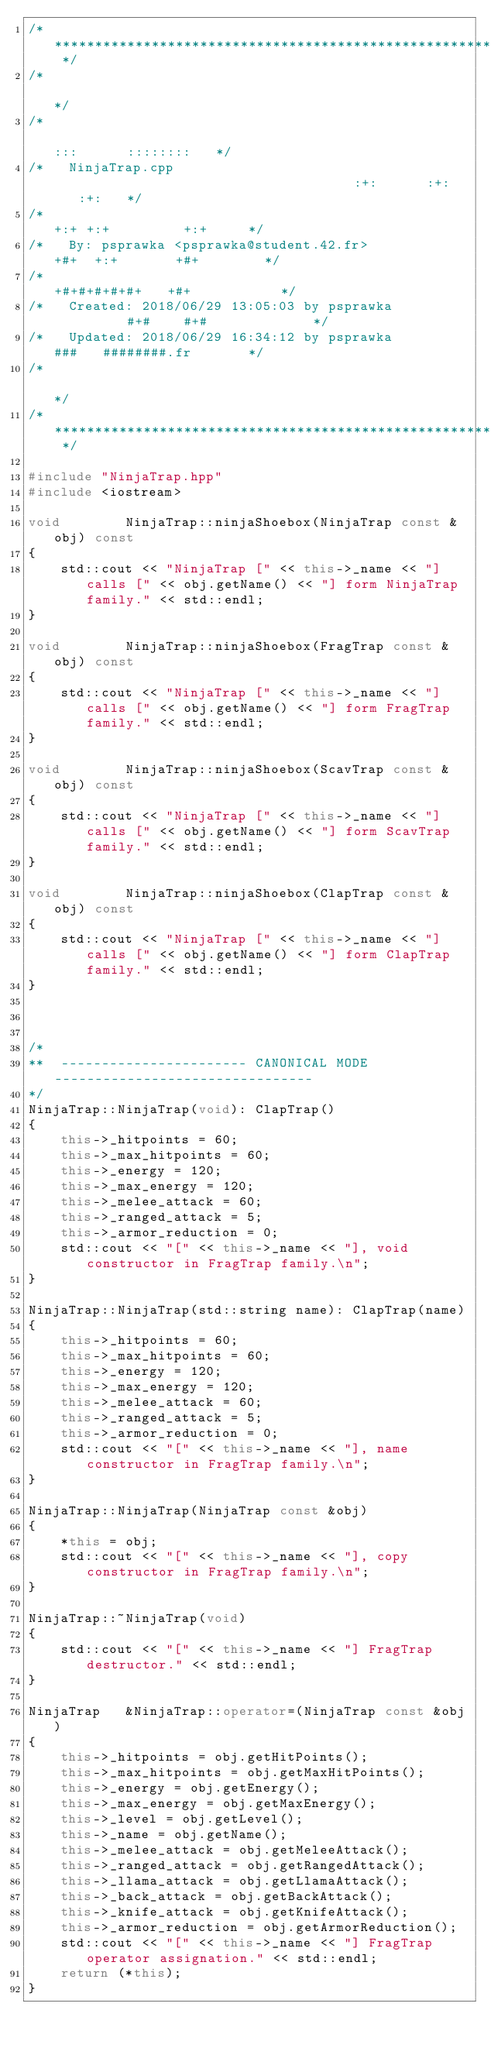Convert code to text. <code><loc_0><loc_0><loc_500><loc_500><_C++_>/* ************************************************************************** */
/*                                                                            */
/*                                                        :::      ::::::::   */
/*   NinjaTrap.cpp                                      :+:      :+:    :+:   */
/*                                                    +:+ +:+         +:+     */
/*   By: psprawka <psprawka@student.42.fr>          +#+  +:+       +#+        */
/*                                                +#+#+#+#+#+   +#+           */
/*   Created: 2018/06/29 13:05:03 by psprawka          #+#    #+#             */
/*   Updated: 2018/06/29 16:34:12 by psprawka         ###   ########.fr       */
/*                                                                            */
/* ************************************************************************** */

#include "NinjaTrap.hpp"
#include <iostream>

void		NinjaTrap::ninjaShoebox(NinjaTrap const &obj) const
{
	std::cout << "NinjaTrap [" << this->_name << "] calls [" << obj.getName() << "] form NinjaTrap family." << std::endl; 
}

void		NinjaTrap::ninjaShoebox(FragTrap const &obj) const
{
	std::cout << "NinjaTrap [" << this->_name << "] calls [" << obj.getName() << "] form FragTrap family." << std::endl; 
}

void		NinjaTrap::ninjaShoebox(ScavTrap const &obj) const
{
	std::cout << "NinjaTrap [" << this->_name << "] calls [" << obj.getName() << "] form ScavTrap family." << std::endl; 
}

void		NinjaTrap::ninjaShoebox(ClapTrap const &obj) const
{
	std::cout << "NinjaTrap [" << this->_name << "] calls [" << obj.getName() << "] form ClapTrap family." << std::endl; 
}



/*
**	----------------------- CANONICAL MODE --------------------------------
*/
NinjaTrap::NinjaTrap(void): ClapTrap()
{
	this->_hitpoints = 60;
	this->_max_hitpoints = 60;
	this->_energy = 120;
	this->_max_energy = 120;
	this->_melee_attack = 60;
	this->_ranged_attack = 5;
	this->_armor_reduction = 0;
	std::cout << "[" << this->_name << "], void constructor in FragTrap family.\n";
}

NinjaTrap::NinjaTrap(std::string name): ClapTrap(name)
{
	this->_hitpoints = 60;
	this->_max_hitpoints = 60;
	this->_energy = 120;
	this->_max_energy = 120;
	this->_melee_attack = 60;
	this->_ranged_attack = 5;
	this->_armor_reduction = 0;
	std::cout << "[" << this->_name << "], name constructor in FragTrap family.\n";
}

NinjaTrap::NinjaTrap(NinjaTrap const &obj)
{
	*this = obj;
	std::cout << "[" << this->_name << "], copy constructor in FragTrap family.\n";
}

NinjaTrap::~NinjaTrap(void)
{
	std::cout << "[" << this->_name << "] FragTrap destructor." << std::endl;
}

NinjaTrap	&NinjaTrap::operator=(NinjaTrap const &obj)
{
	this->_hitpoints = obj.getHitPoints();
	this->_max_hitpoints = obj.getMaxHitPoints();
	this->_energy = obj.getEnergy();
	this->_max_energy = obj.getMaxEnergy();
	this->_level = obj.getLevel();
	this->_name = obj.getName();
	this->_melee_attack = obj.getMeleeAttack();
	this->_ranged_attack = obj.getRangedAttack();
	this->_llama_attack = obj.getLlamaAttack();
	this->_back_attack = obj.getBackAttack();
	this->_knife_attack = obj.getKnifeAttack();
	this->_armor_reduction = obj.getArmorReduction();
	std::cout << "[" << this->_name << "] FragTrap operator assignation." << std::endl;
	return (*this);
}

</code> 